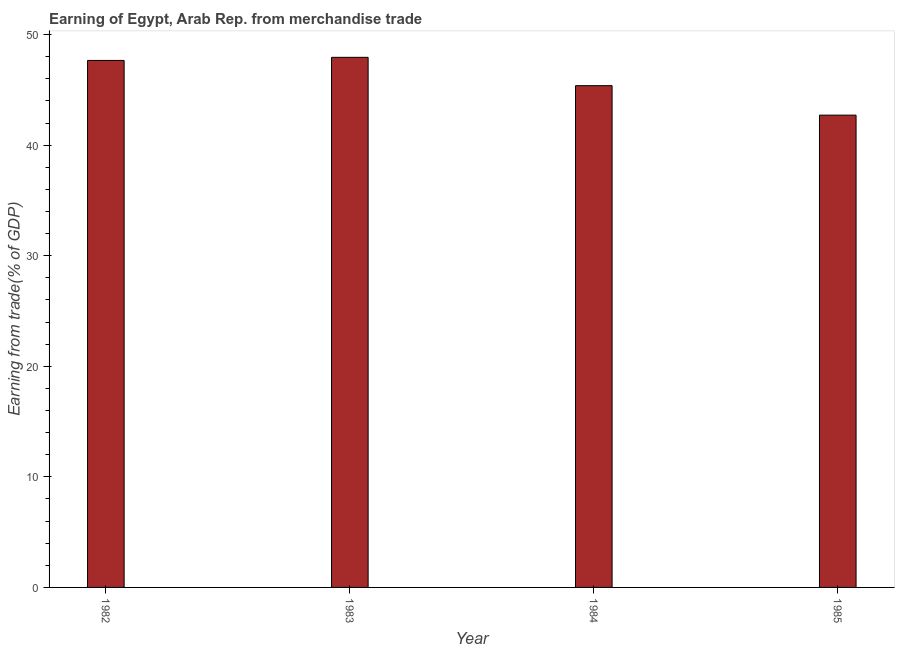What is the title of the graph?
Keep it short and to the point. Earning of Egypt, Arab Rep. from merchandise trade. What is the label or title of the Y-axis?
Your answer should be very brief. Earning from trade(% of GDP). What is the earning from merchandise trade in 1985?
Make the answer very short. 42.72. Across all years, what is the maximum earning from merchandise trade?
Your answer should be compact. 47.94. Across all years, what is the minimum earning from merchandise trade?
Your answer should be compact. 42.72. What is the sum of the earning from merchandise trade?
Offer a very short reply. 183.7. What is the difference between the earning from merchandise trade in 1982 and 1984?
Keep it short and to the point. 2.28. What is the average earning from merchandise trade per year?
Provide a short and direct response. 45.93. What is the median earning from merchandise trade?
Offer a very short reply. 46.52. In how many years, is the earning from merchandise trade greater than 6 %?
Make the answer very short. 4. What is the ratio of the earning from merchandise trade in 1984 to that in 1985?
Ensure brevity in your answer.  1.06. Is the earning from merchandise trade in 1983 less than that in 1984?
Your response must be concise. No. Is the difference between the earning from merchandise trade in 1982 and 1983 greater than the difference between any two years?
Provide a short and direct response. No. What is the difference between the highest and the second highest earning from merchandise trade?
Make the answer very short. 0.28. Is the sum of the earning from merchandise trade in 1982 and 1984 greater than the maximum earning from merchandise trade across all years?
Your answer should be compact. Yes. What is the difference between the highest and the lowest earning from merchandise trade?
Make the answer very short. 5.23. How many years are there in the graph?
Provide a succinct answer. 4. What is the Earning from trade(% of GDP) in 1982?
Your answer should be very brief. 47.66. What is the Earning from trade(% of GDP) of 1983?
Offer a terse response. 47.94. What is the Earning from trade(% of GDP) in 1984?
Give a very brief answer. 45.38. What is the Earning from trade(% of GDP) in 1985?
Offer a very short reply. 42.72. What is the difference between the Earning from trade(% of GDP) in 1982 and 1983?
Your response must be concise. -0.28. What is the difference between the Earning from trade(% of GDP) in 1982 and 1984?
Provide a succinct answer. 2.28. What is the difference between the Earning from trade(% of GDP) in 1982 and 1985?
Your answer should be very brief. 4.95. What is the difference between the Earning from trade(% of GDP) in 1983 and 1984?
Your response must be concise. 2.56. What is the difference between the Earning from trade(% of GDP) in 1983 and 1985?
Give a very brief answer. 5.23. What is the difference between the Earning from trade(% of GDP) in 1984 and 1985?
Give a very brief answer. 2.66. What is the ratio of the Earning from trade(% of GDP) in 1982 to that in 1985?
Your response must be concise. 1.12. What is the ratio of the Earning from trade(% of GDP) in 1983 to that in 1984?
Ensure brevity in your answer.  1.06. What is the ratio of the Earning from trade(% of GDP) in 1983 to that in 1985?
Give a very brief answer. 1.12. What is the ratio of the Earning from trade(% of GDP) in 1984 to that in 1985?
Your answer should be very brief. 1.06. 